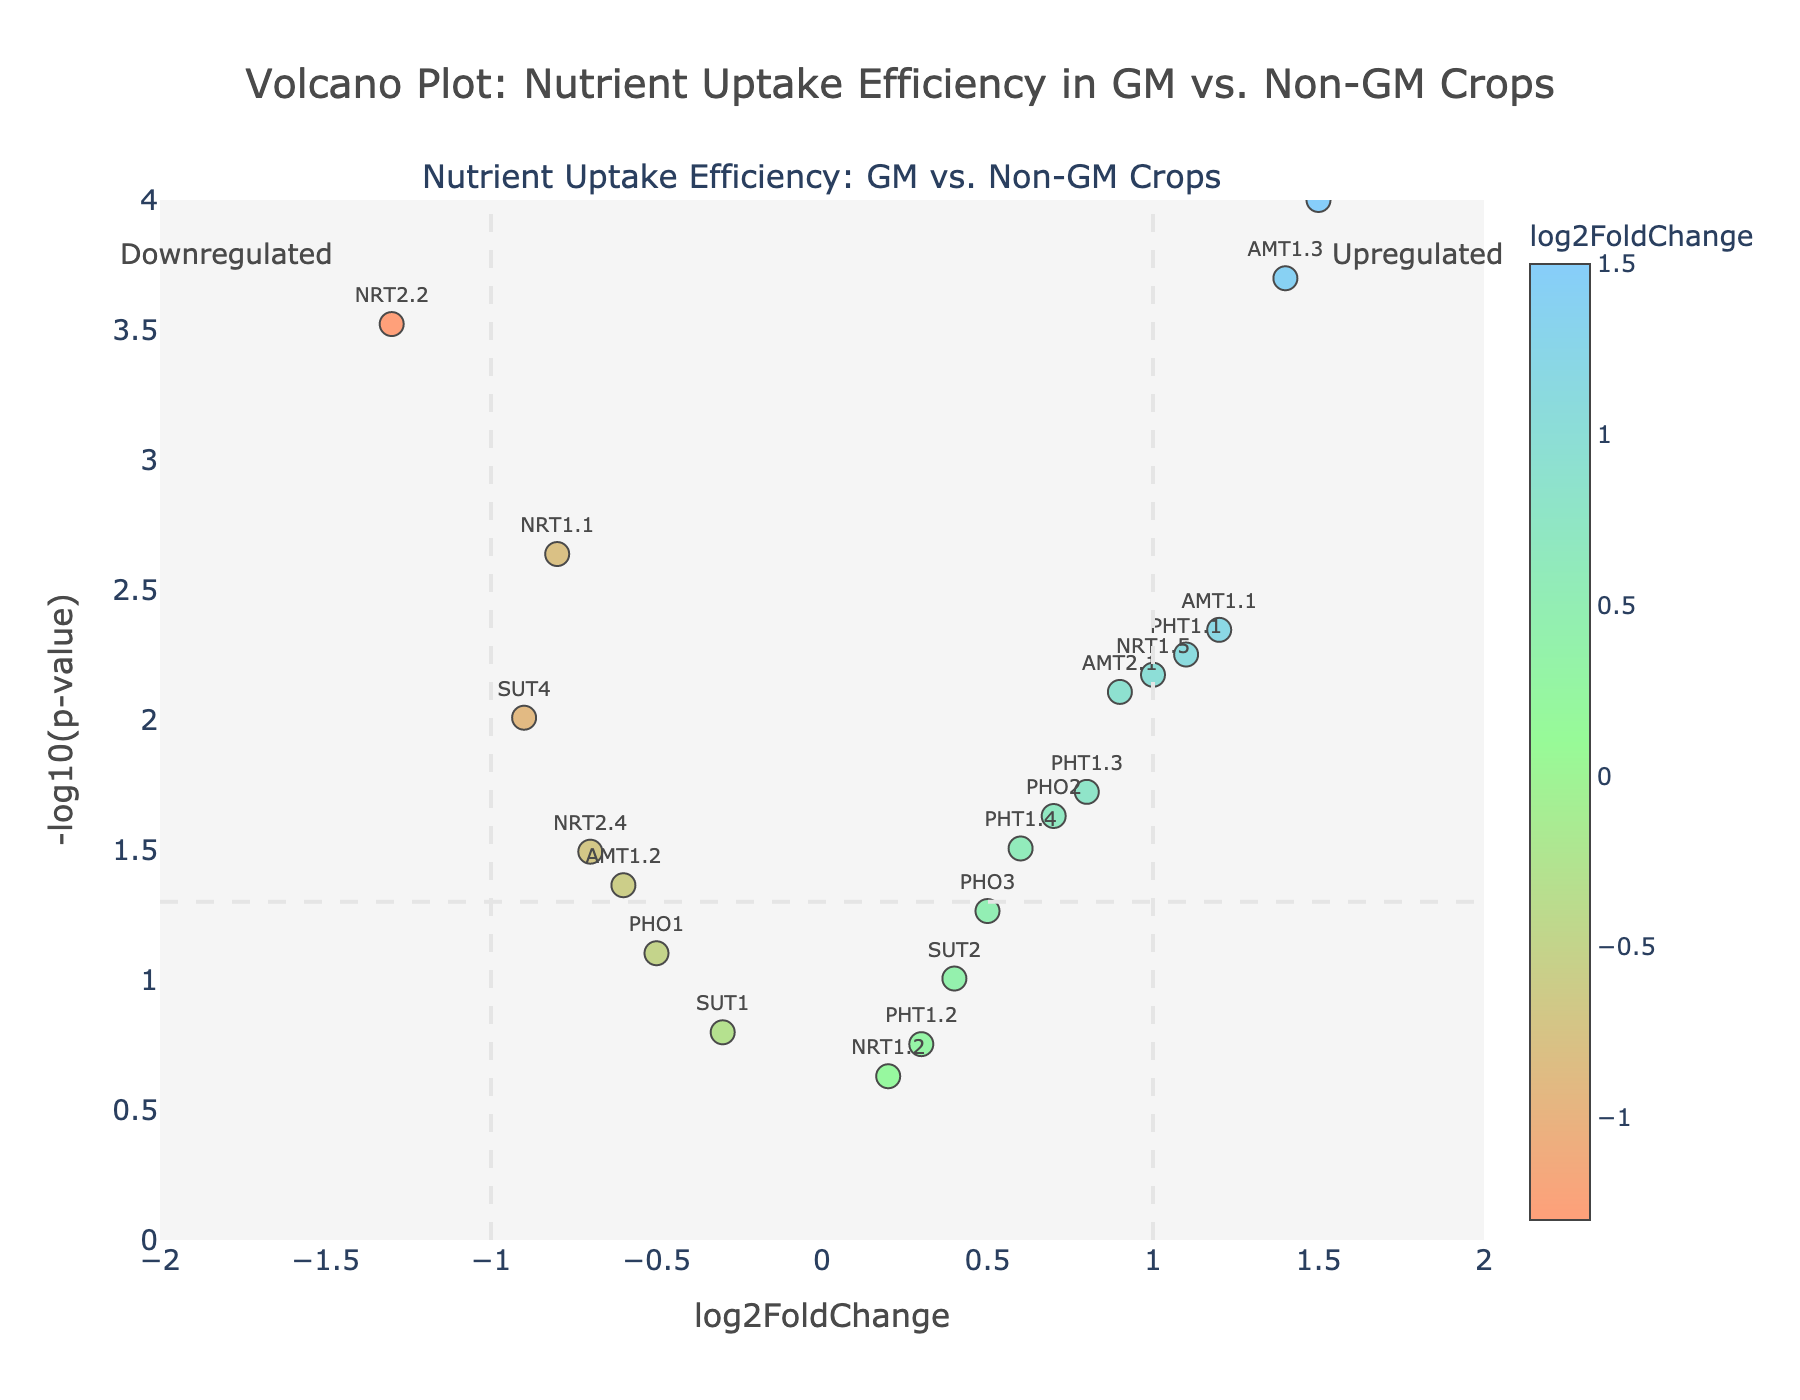What is the title of the figure? The title of the figure can be seen at the top and reads: "Volcano Plot: Nutrient Uptake Efficiency in GM vs. Non-GM Crops"
Answer: Volcano Plot: Nutrient Uptake Efficiency in GM vs. Non-GM Crops What does the x-axis represent? The x-axis is labeled 'log2FoldChange,' indicating the log2 transformation of the fold change in nutrient uptake efficiency between GM and non-GM crops.
Answer: log2FoldChange What does the y-axis represent? The y-axis is labeled '-log10(p-value),' indicating the negative log10 transformation of the p-values for statistical significance of nutrient uptake efficiency comparisons.
Answer: -log10(p-value) How many genes have a p-value less than 0.05? Genes with p-values less than 0.05 will have their -log10(p-value) greater than 1.3 (since -log10(0.05) ≈ 1.3). Count the number of points above this horizontal threshold line.
Answer: 13 Which gene is the most upregulated in GM crops? The most upregulated gene will have the highest positive log2FoldChange value. In this case, the gene 'NRT2.1' has the highest log2FoldChange value of 1.5.
Answer: NRT2.1 Which gene is most significantly downregulated in non-GM crops? The most significantly downregulated gene will have the lowest log2FoldChange value and a high -log10(p-value). The gene 'NRT2.2' has a log2FoldChange of -1.3 and is highly significant (low p-value).
Answer: NRT2.2 What is the 'log2FoldChange' and 'p-value' for the gene 'AMT1.3'? Hovering over the point labeled 'AMT1.3' will show its details: log2FoldChange = 1.4, p-value = 0.0002
Answer: log2FoldChange: 1.4, p-value: 0.0002 How many genes have a log2FoldChange between -0.5 and 0.5? Count the number of data points within the range of -0.5 and 0.5 on the x-axis regardless of their p-value.
Answer: 6 Which genes are highly significant (p-value < 0.01) and upregulated (log2FoldChange > 1)? Identifying genes with -log10(p-value) > 2 (hence, p-value < 0.01) and log2FoldChange > 1. The genes 'NRT2.1' and 'AMT1.3' meet these criteria.
Answer: NRT2.1, AMT1.3 In which direction (upregulated/downregulated) are most significant genes (p-value < 0.05)? By determining the direction of the log2FoldChange (either positive for upregulated or negative for downregulated) for genes with -log10(p-value) > 1.3, most of them are positive.
Answer: Upregulated 